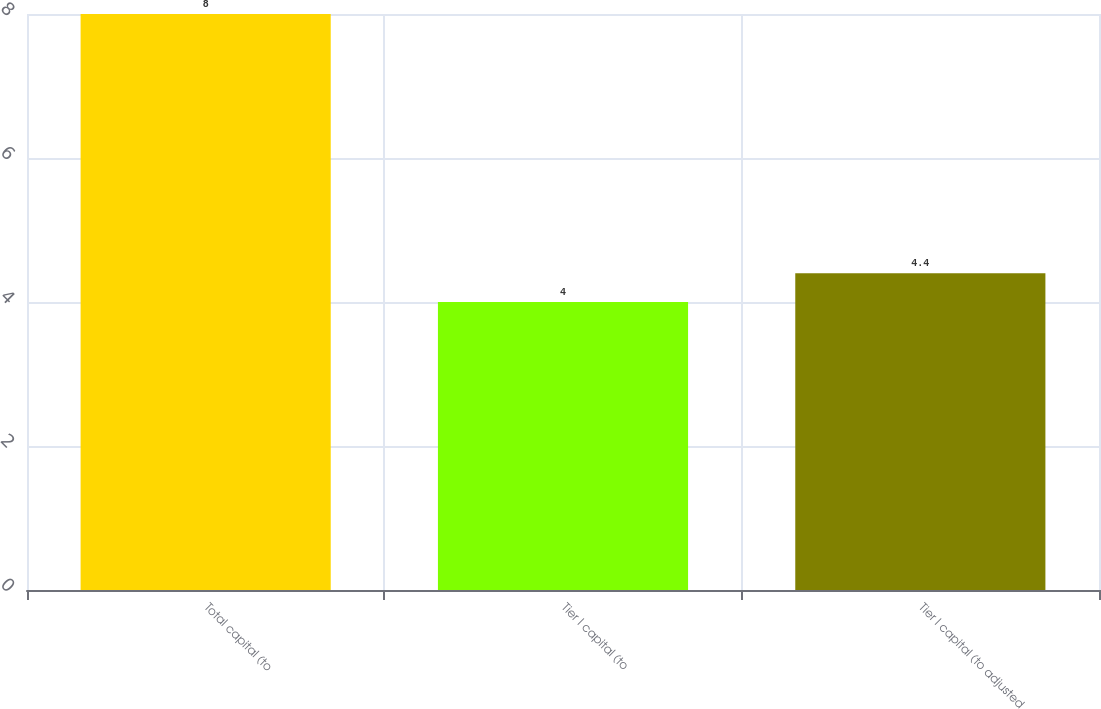Convert chart. <chart><loc_0><loc_0><loc_500><loc_500><bar_chart><fcel>Total capital (to<fcel>Tier I capital (to<fcel>Tier I capital (to adjusted<nl><fcel>8<fcel>4<fcel>4.4<nl></chart> 